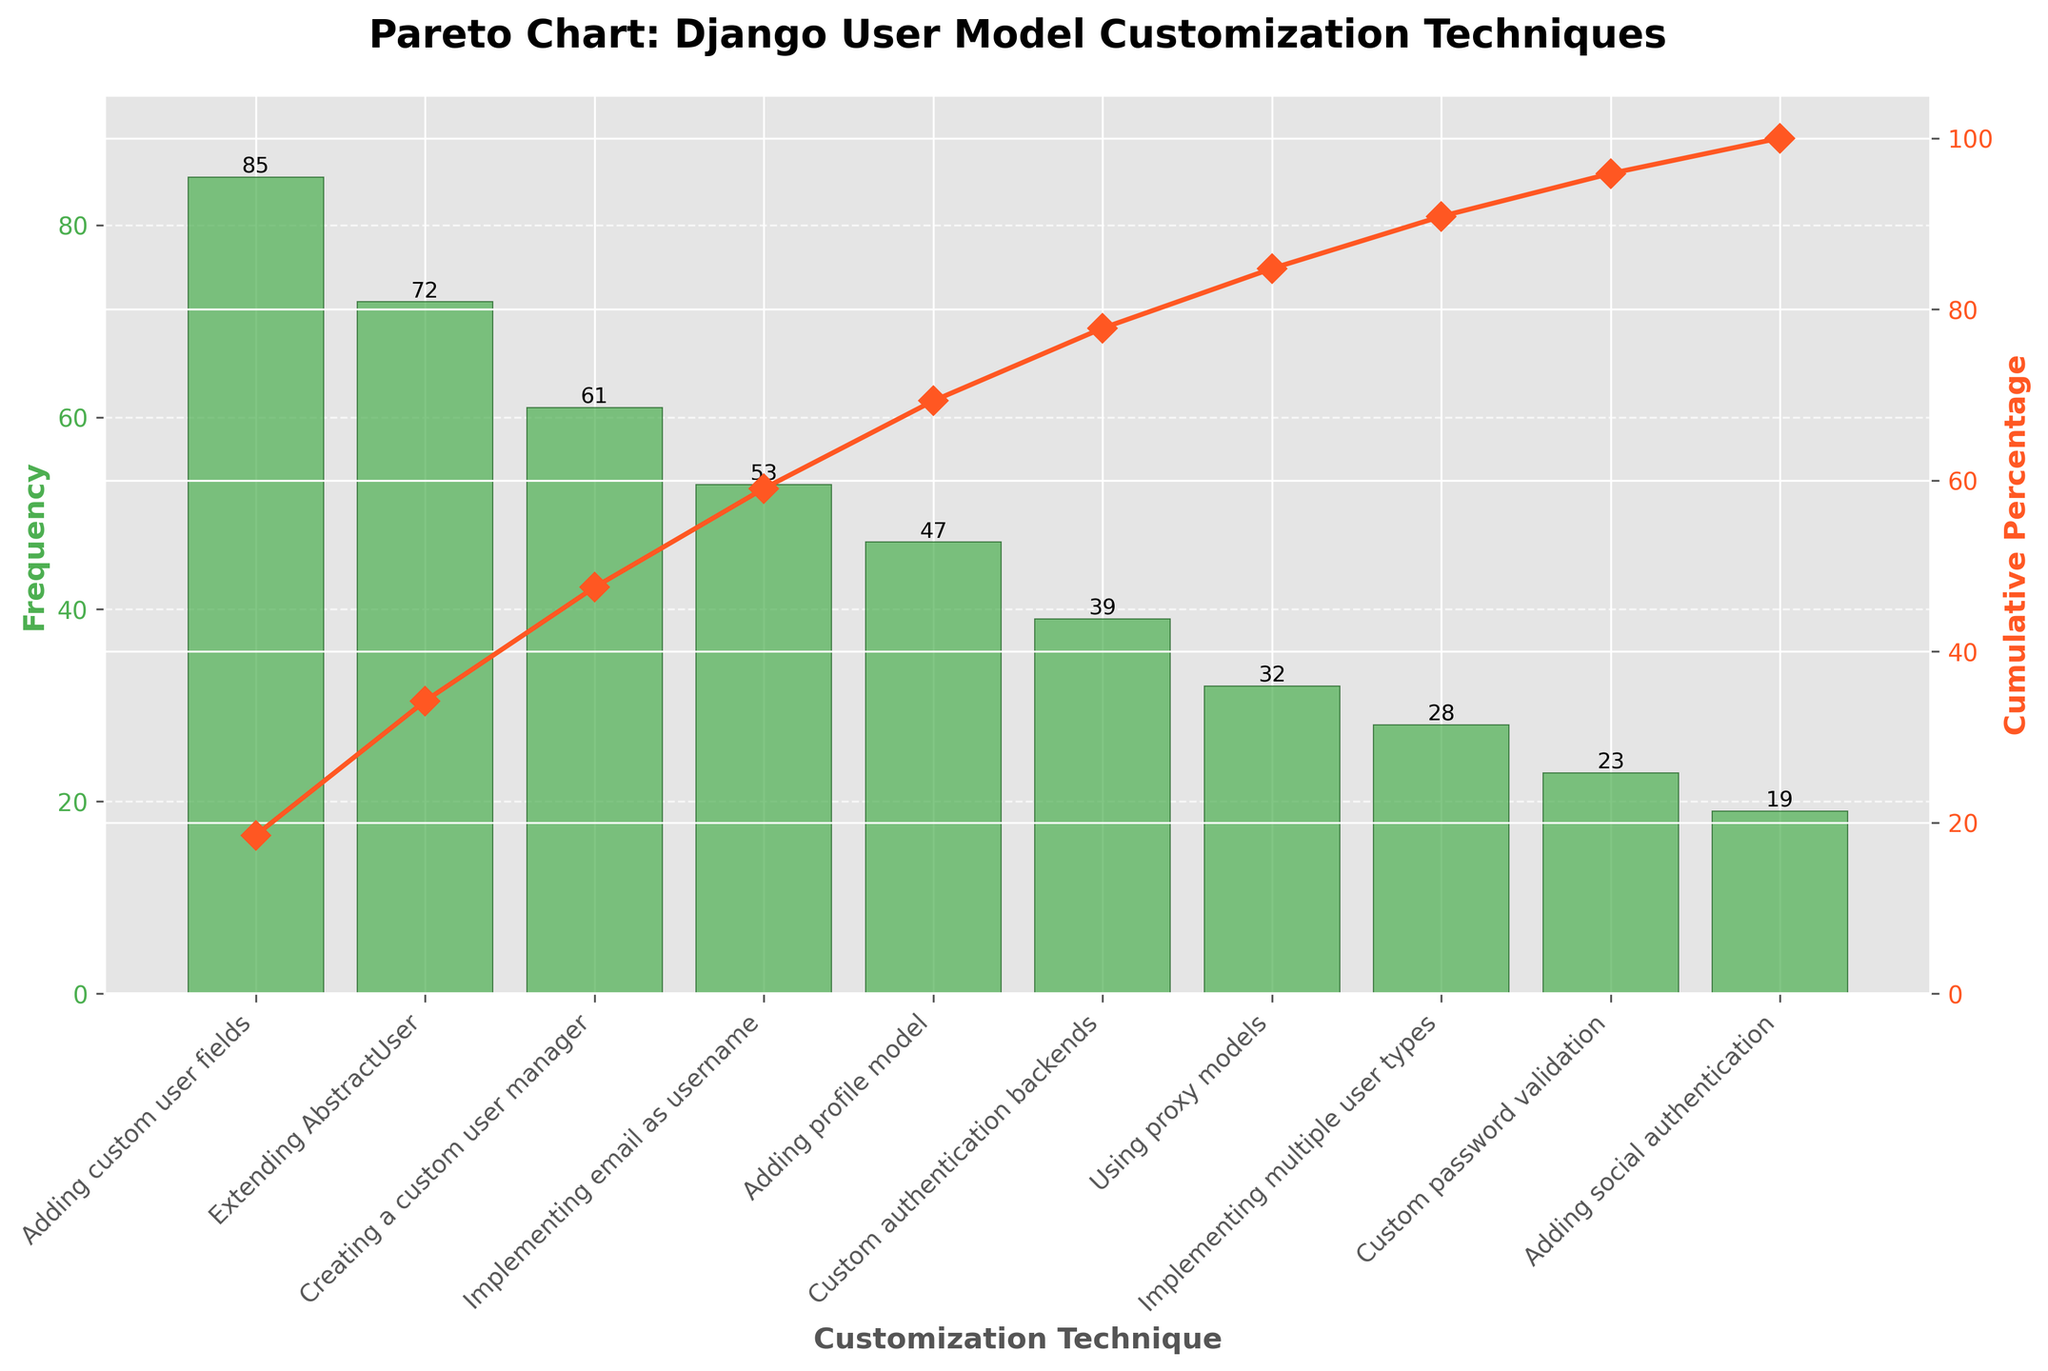What is the total frequency for the customization technique "Adding custom user fields"? The bar for "Adding custom user fields" reaches up to 85 on the y-axis, indicating its frequency.
Answer: 85 What percentage of the total does "Extending AbstractUser" contribute to? The cumulative percentage line shows that "Extending AbstractUser," second on the list, brings the cumulative percentage up to around 72/335 * 100 = 21.5%.
Answer: 21.5% Which customization techniques have a frequency lower than 30? According to the bar heights, "Implementing multiple user types," "Custom password validation," and "Adding social authentication" each have frequencies below 30.
Answer: Three techniques What is the cumulative percentage after the top three customization techniques? Adding the frequencies of the top three techniques: 85 (Adding custom user fields) + 72 (Extending AbstractUser) + 61 (Creating a custom user manager) = 218, which is approximately 218/335 * 100 = 65.07%.
Answer: 65.07% How many customization techniques have been plotted in total? Count the number of bars in the chart, which corresponds to the number of distinct techniques. There are 10 bars.
Answer: 10 Which customization technique has the highest frequency, and what is its cumulative percentage? "Adding custom user fields" has the highest frequency of 85, contributing to a cumulative percentage of 85/335 * 100 = 25.37%.
Answer: 25.37% What is the difference in frequency between "Custom authentication backends" and "Adding profile model"? The frequency for "Custom authentication backends" is 39 and for "Adding profile model" is 47. Thus, the difference is 47 - 39 = 8.
Answer: 8 What range of frequencies do the customization techniques span? The lowest frequency is for "Adding social authentication" at 19, and the highest is for "Adding custom user fields" at 85. Thus, the range is 85 - 19 = 66.
Answer: 66 At what point (technique) does the cumulative percentage surpass 50%? Adding the frequencies of the top two techniques: 85 + 72 = 157, which is approximately 157/335 * 100 = 46.87%. Adding the third technique brings the total to 218, surpassing 50%. Thus, "Creating a custom user manager" surpasses 50%.
Answer: Creating a custom user manager 